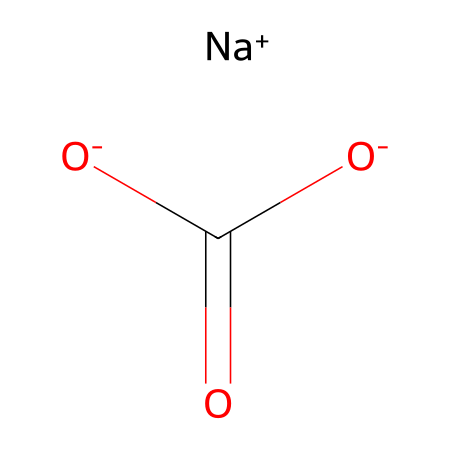How many sodium atoms are in baking soda? The chemical structure contains the notation "[Na+]", which indicates the presence of one sodium atom that carries a positive charge.
Answer: one What is the molecular formula of baking soda? The chemical structure shows the components: sodium (Na), carbon (C), and oxygen (O) in a listed format, translating to the molecular formula NaHCO3.
Answer: NaHCO3 What type of ion is present in baking soda? The structure indicates there is a positive sodium ion "[Na+]" and a negative bicarbonate ion "C(=O)[O-]", indicating a balance of charges typical for bases.
Answer: ion What is the total number of oxygen atoms in baking soda? Examining the structure, there are three oxygen atoms: two from the carboxylate group (C(=O)[O-]) and one from the bicarbonate.
Answer: three What role does baking soda play in acid-base reactions? Baking soda acts as a Bronsted-Lowry base which accepts protons in reactions due to the presence of the bicarbonate ion, contributing to the overall basicity of the compound.
Answer: base What functional group is present in baking soda? The structure contains the carboxylate ion (C(=O)[O-]), which signifies that baking soda includes the carboxylate functional group.
Answer: carboxylate How many hydrogen atoms are in the molecular structure of baking soda? The chemical representation indicates there is one hydrogen atom attached to the bicarbonate (NaHCO3), thereby confirming the presence of one hydrogen atom in total.
Answer: one 